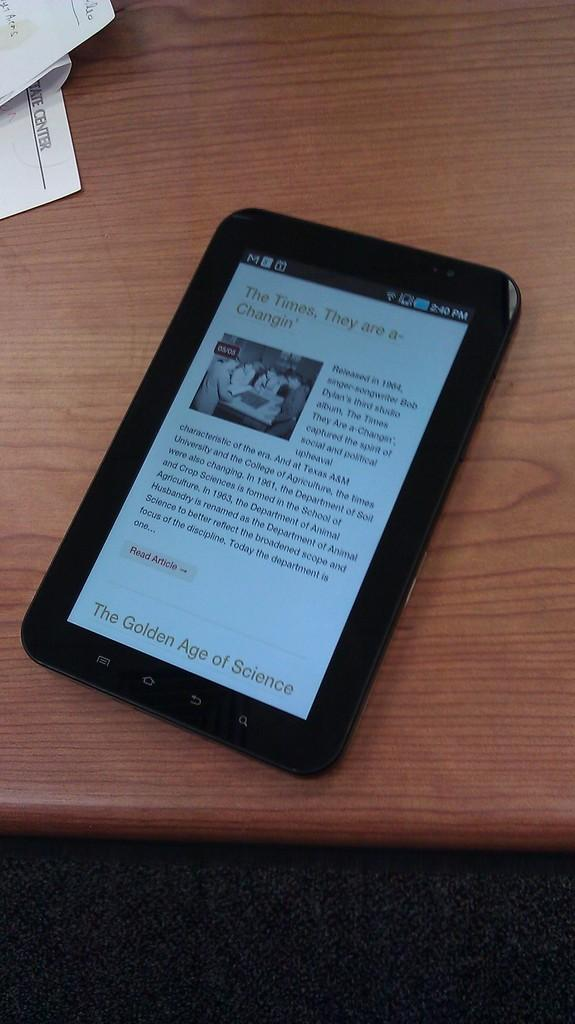What is the main object in the image? There is a table in the image. What is placed on the table? There is a tablet PC on the table. Are there any additional items on the table? Yes, there are papers on the left side of the table. What type of poison is being used on the tablet PC in the image? There is no poison present in the image; it features a table with a tablet PC and papers. Is there any blood visible on the papers in the image? There is no blood visible on the papers in the image. 